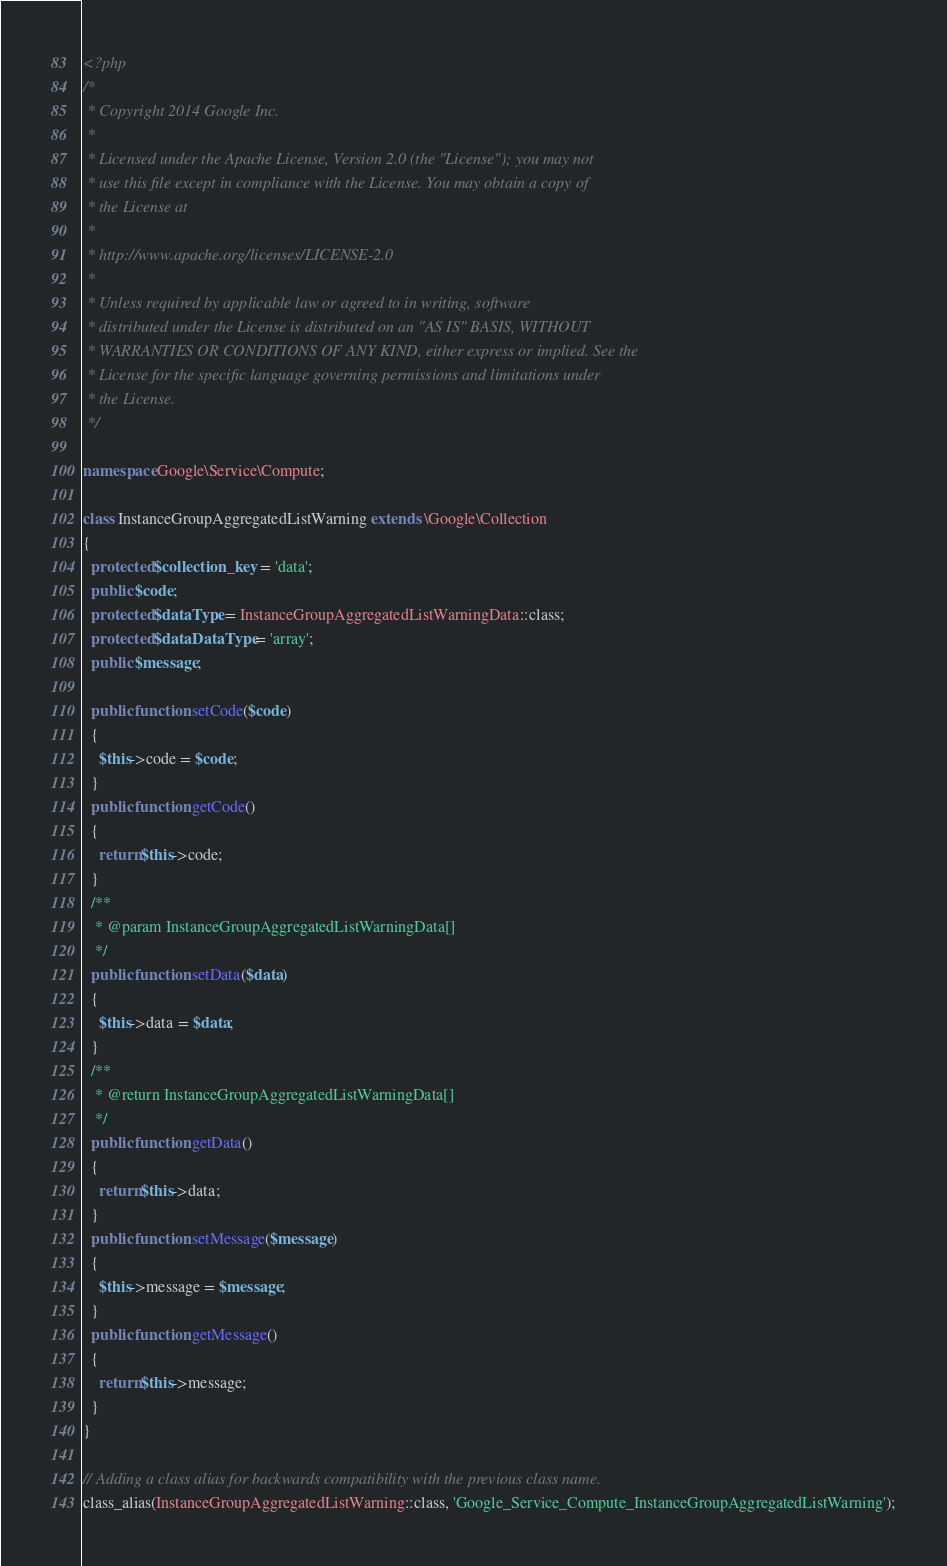<code> <loc_0><loc_0><loc_500><loc_500><_PHP_><?php
/*
 * Copyright 2014 Google Inc.
 *
 * Licensed under the Apache License, Version 2.0 (the "License"); you may not
 * use this file except in compliance with the License. You may obtain a copy of
 * the License at
 *
 * http://www.apache.org/licenses/LICENSE-2.0
 *
 * Unless required by applicable law or agreed to in writing, software
 * distributed under the License is distributed on an "AS IS" BASIS, WITHOUT
 * WARRANTIES OR CONDITIONS OF ANY KIND, either express or implied. See the
 * License for the specific language governing permissions and limitations under
 * the License.
 */

namespace Google\Service\Compute;

class InstanceGroupAggregatedListWarning extends \Google\Collection
{
  protected $collection_key = 'data';
  public $code;
  protected $dataType = InstanceGroupAggregatedListWarningData::class;
  protected $dataDataType = 'array';
  public $message;

  public function setCode($code)
  {
    $this->code = $code;
  }
  public function getCode()
  {
    return $this->code;
  }
  /**
   * @param InstanceGroupAggregatedListWarningData[]
   */
  public function setData($data)
  {
    $this->data = $data;
  }
  /**
   * @return InstanceGroupAggregatedListWarningData[]
   */
  public function getData()
  {
    return $this->data;
  }
  public function setMessage($message)
  {
    $this->message = $message;
  }
  public function getMessage()
  {
    return $this->message;
  }
}

// Adding a class alias for backwards compatibility with the previous class name.
class_alias(InstanceGroupAggregatedListWarning::class, 'Google_Service_Compute_InstanceGroupAggregatedListWarning');
</code> 